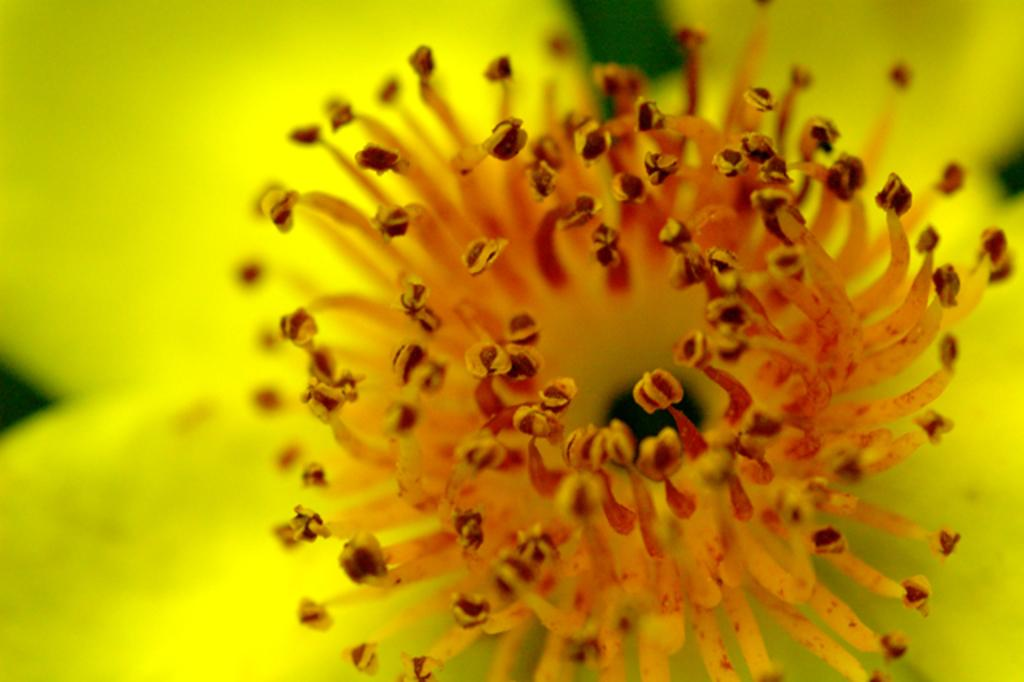What is the main subject of the image? There is a flower in the image. Can you describe the background of the image? The background of the image is blurred. Can you see a bee buzzing around the flower in the image? There is no bee visible in the image. What type of slope is present in the image? There is no slope present in the image. Is there a collar visible on the flower in the image? There is no collar visible on the flower in the image. 